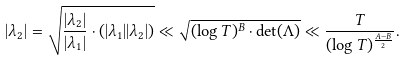<formula> <loc_0><loc_0><loc_500><loc_500>| \lambda _ { 2 } | = \sqrt { \frac { | \lambda _ { 2 } | } { | \lambda _ { 1 } | } \cdot ( | \lambda _ { 1 } | | \lambda _ { 2 } | ) } \ll \sqrt { ( \log T ) ^ { B } \cdot \det ( \Lambda ) } \ll \frac { T } { ( \log T ) ^ { \frac { A - B } { 2 } } } .</formula> 